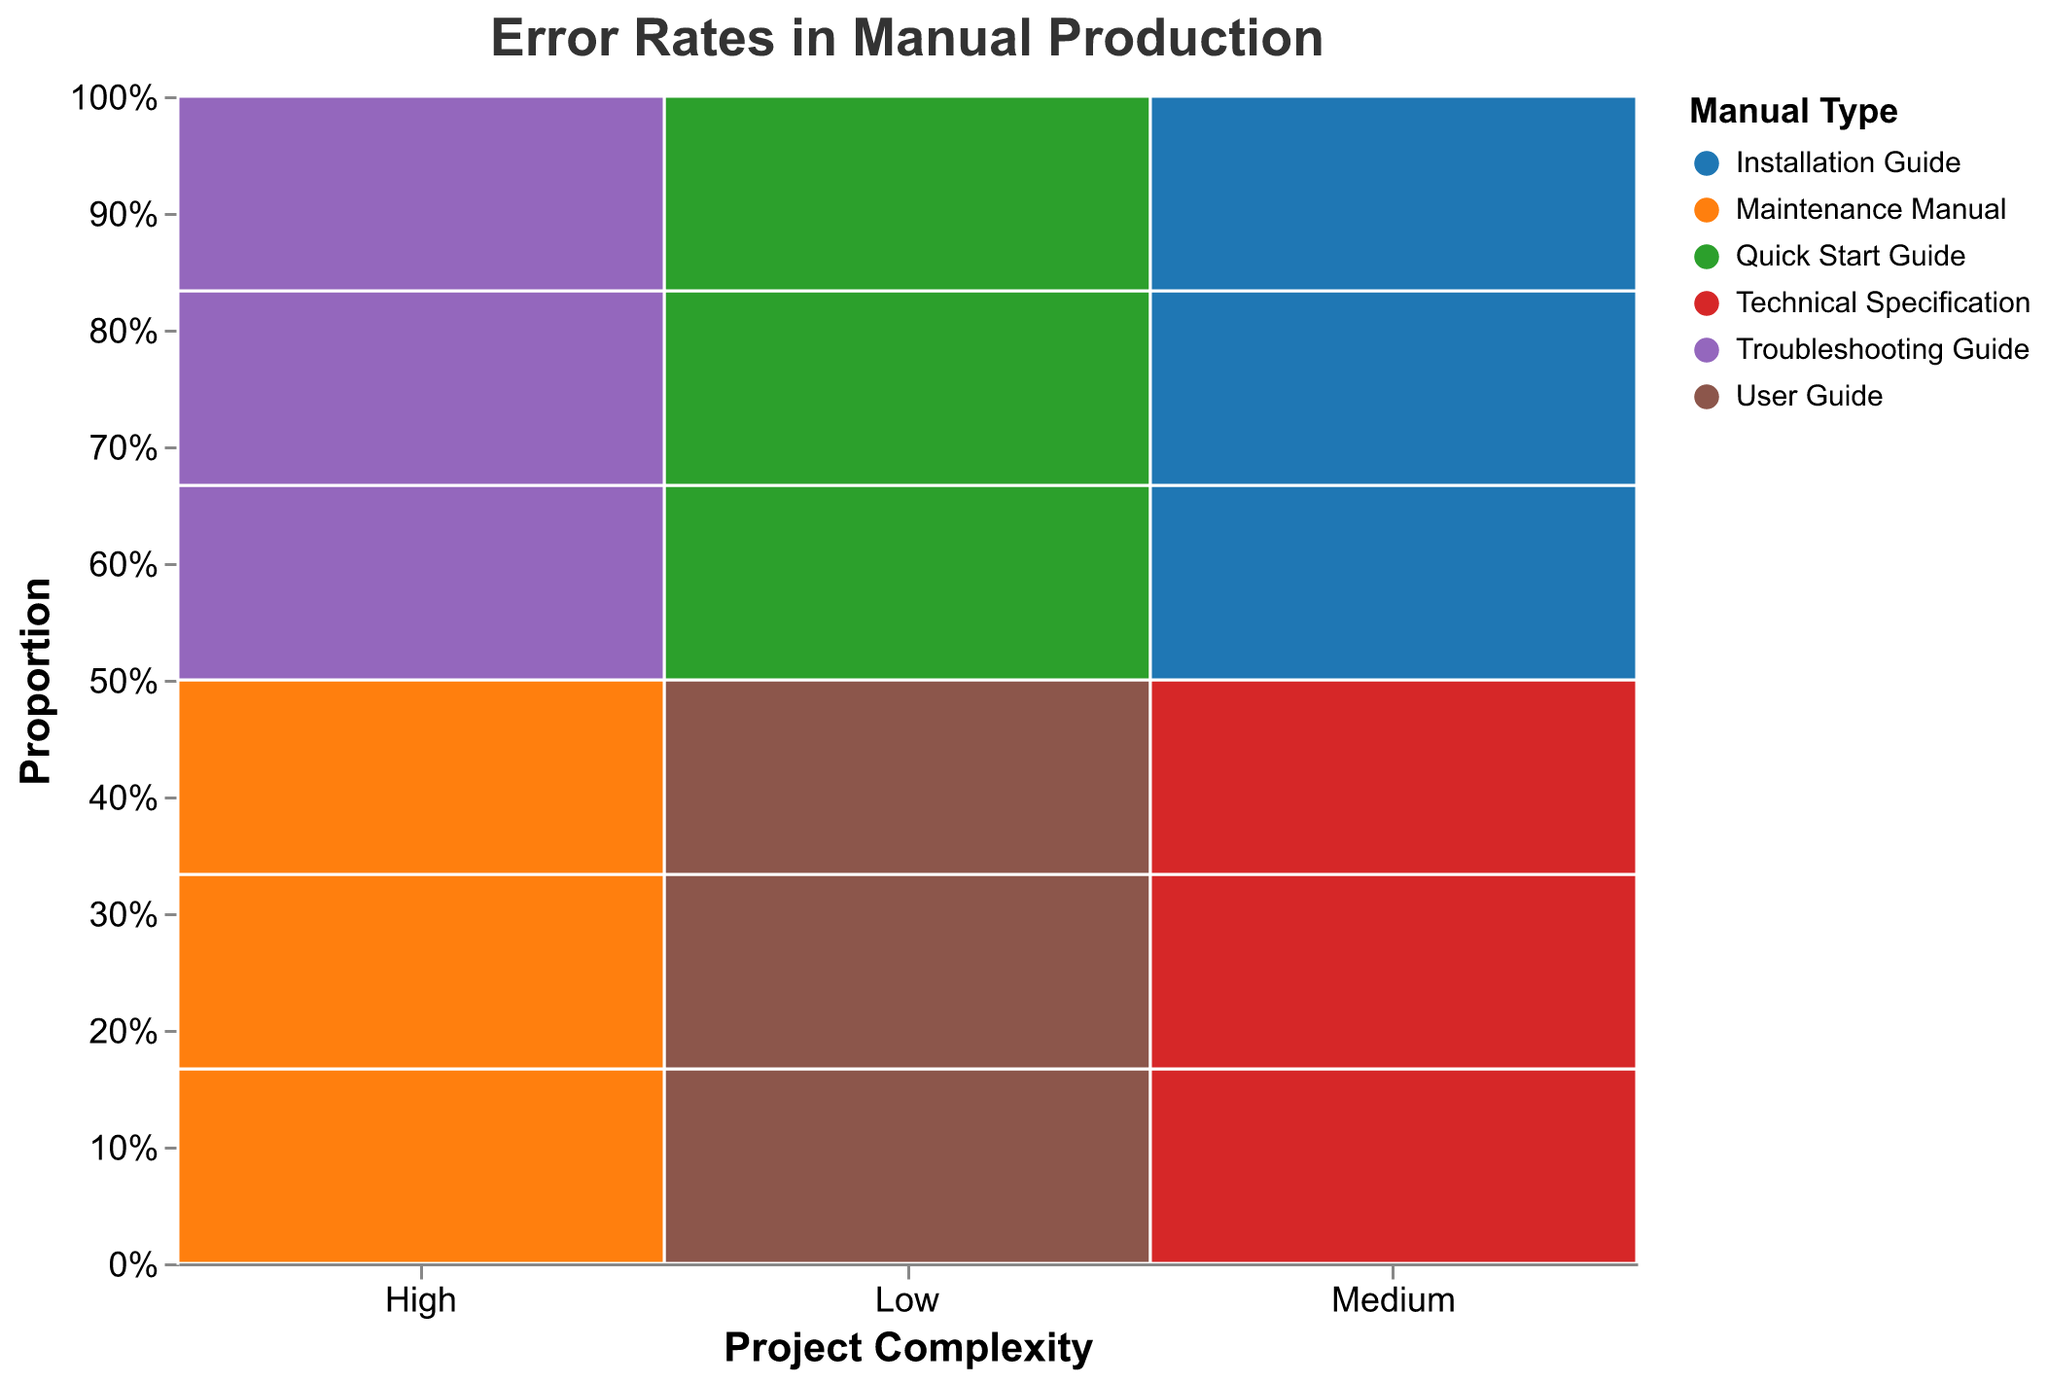What is the overall title of the figure? The title of the figure is displayed prominently at the top in large, bold font. This helps quickly understand the main theme of the visualization.
Answer: Error Rates in Manual Production How many levels of project complexity are shown in the figure? The x-axis labeled "Project Complexity" divides the data into categories. Observing the unique labels on the x-axis provides the count.
Answer: 3 Which manual type has the highest error rate for high project complexity in 1-2 revision rounds? By looking at the colors representing different manual types and focusing on the "High" project complexity column, identify the section with the highest "1-2" revision rounds proportion.
Answer: Troubleshooting Guide As project complexity increases, how does the error rate trend change for the Maintenance Manual? Evaluate the trend in error rates across different project complexity levels by comparing the heights of the segments for Maintenance Manual.
Answer: Error rate decreases What is the error rate difference between Quick Start Guide and Troubleshooting Guide in medium complexity for 3-4 revisions? Identify and compare the segments representing error rates for Quick Start Guide and Troubleshooting Guide in the medium complexity category for 3-4 revision rounds using the heights of segments.
Answer: 3.5% Which combination of project complexity and revision rounds appears to lead to the lowest error rates? Look for the segment with the smallest proportion in all combinations of project complexity and revision rounds, as indicated by the shortest height.
Answer: Low complexity, 5+ rounds Is there any notable pattern in error rates across different manual types as revision rounds increase? Analyze the segments across different project complexities to observe changes in error rates with increasing revision rounds for each manual type.
Answer: Error rates generally decrease How do error rates compare between User Guide and Installation Guide for medium complexity and 1-2 revision rounds? Compare the segments representing these manual types within the "Medium" project complexity column at 1-2 revision rounds by examining the heights of the segments.
Answer: User Guide has a lower error rate Which manual type is associated with the highest error rate for low complexity for 1-2 revisions? Focus on the "Low" project complexity column and identify the color corresponding to the highest error rate segment for 1-2 revision rounds.
Answer: Quick Start Guide 